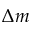<formula> <loc_0><loc_0><loc_500><loc_500>\Delta m</formula> 